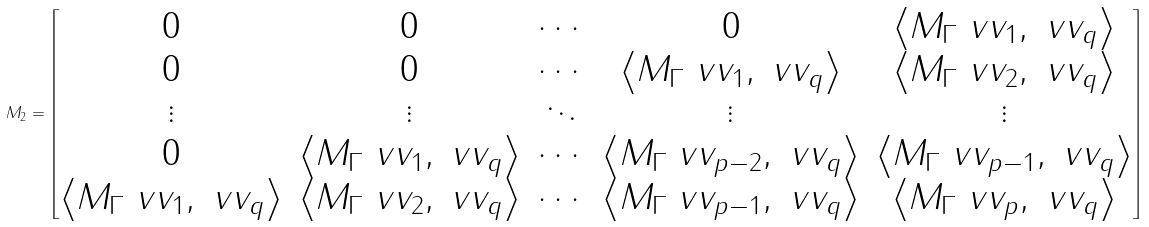Convert formula to latex. <formula><loc_0><loc_0><loc_500><loc_500>M _ { 2 } = \begin{bmatrix} 0 & 0 & \cdots & 0 & \left \langle M _ { \Gamma } \ v v _ { 1 } , \ v v _ { q } \right \rangle \\ 0 & 0 & \cdots & \left \langle M _ { \Gamma } \ v v _ { 1 } , \ v v _ { q } \right \rangle & \left \langle M _ { \Gamma } \ v v _ { 2 } , \ v v _ { q } \right \rangle \\ \vdots & \vdots & \ddots & \vdots & \vdots \\ 0 & \left \langle M _ { \Gamma } \ v v _ { 1 } , \ v v _ { q } \right \rangle & \cdots & \left \langle M _ { \Gamma } \ v v _ { p - 2 } , \ v v _ { q } \right \rangle & \left \langle M _ { \Gamma } \ v v _ { p - 1 } , \ v v _ { q } \right \rangle \\ \left \langle M _ { \Gamma } \ v v _ { 1 } , \ v v _ { q } \right \rangle & \left \langle M _ { \Gamma } \ v v _ { 2 } , \ v v _ { q } \right \rangle & \cdots & \left \langle M _ { \Gamma } \ v v _ { p - 1 } , \ v v _ { q } \right \rangle & \left \langle M _ { \Gamma } \ v v _ { p } , \ v v _ { q } \right \rangle \end{bmatrix}</formula> 